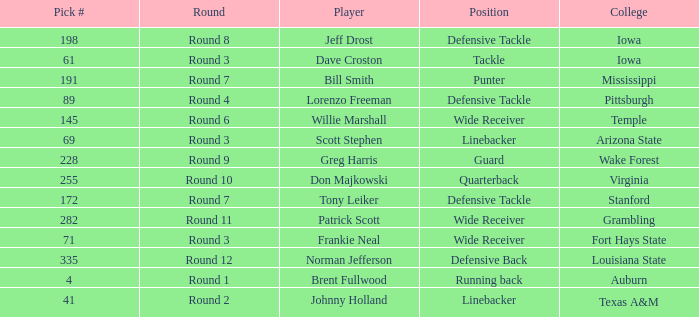What is the largest pick# for Greg Harris? 228.0. 